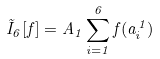<formula> <loc_0><loc_0><loc_500><loc_500>\tilde { I } _ { 6 } [ f ] = A _ { 1 } \sum _ { i = 1 } ^ { 6 } f ( a _ { i } ^ { 1 } )</formula> 